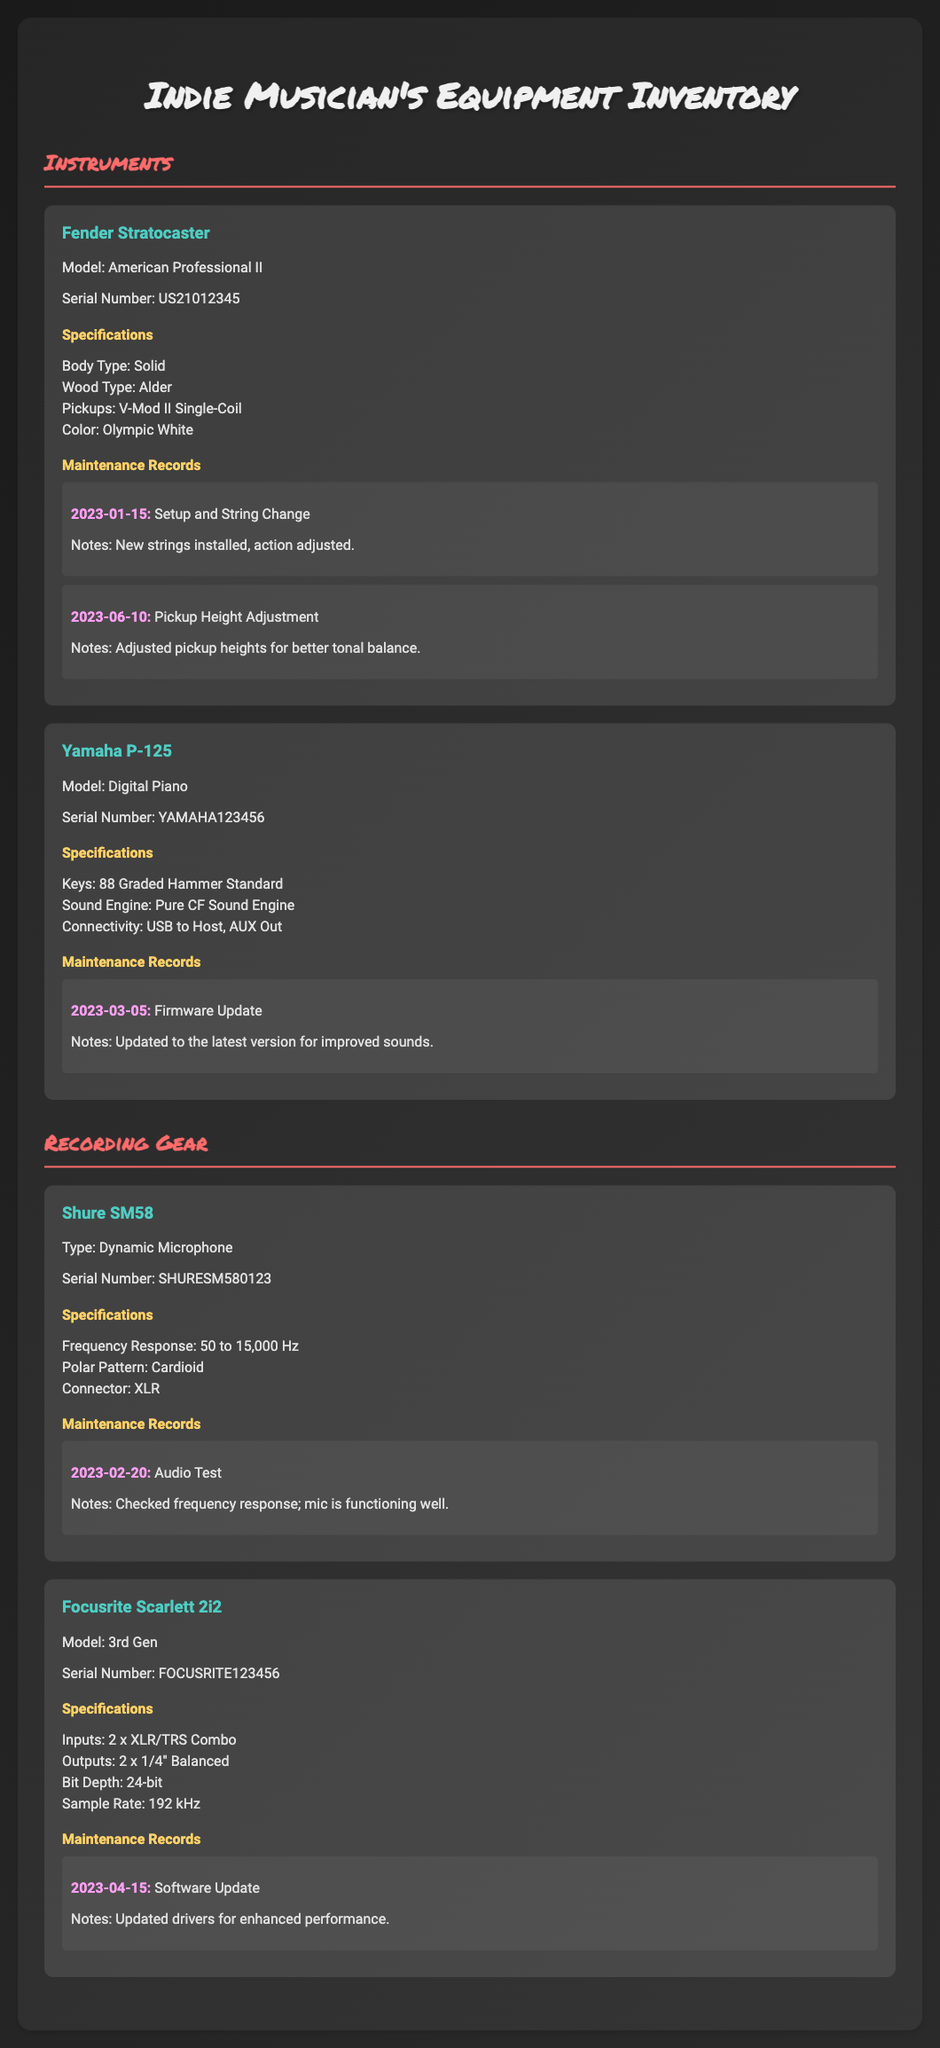what is the model of the Fender Stratocaster? The model of the Fender Stratocaster is American Professional II, as specified in the document.
Answer: American Professional II what is the serial number of the Yamaha P-125? The serial number is a unique identifier found in the specifications of the Yamaha P-125 section.
Answer: YAMAHA123456 when was the firmware update for the Yamaha P-125 performed? The document provides the date of maintenance records for the Yamaha P-125, showing when tasks were completed.
Answer: 2023-03-05 what is the frequency response range of the Shure SM58 microphone? The frequency response range is listed in the specifications for the Shure SM58, indicating its performance range.
Answer: 50 to 15,000 Hz how many maintenance records are listed for the Fender Stratocaster? The total number of maintenance records can be counted from the section dedicated to the Fender Stratocaster.
Answer: 2 which instrument has a solid body type? The body type for each instrument is listed under its specifications, indicating characteristics such as shape and material.
Answer: Fender Stratocaster what is the sample rate of the Focusrite Scarlett 2i2? The sample rate is provided in the specifications for the Focusrite Scarlett 2i2, detailing its audio quality capabilities.
Answer: 192 kHz what type of gear is the Shure SM58? The type of gear for the Shure SM58 is mentioned in the title of its section, indicating what kind of equipment it is classified as.
Answer: Dynamic Microphone what kind of wood is used for the body of the Fender Stratocaster? The type of wood used is specified in the product details of the Fender Stratocaster, which contributes to its sound.
Answer: Alder 